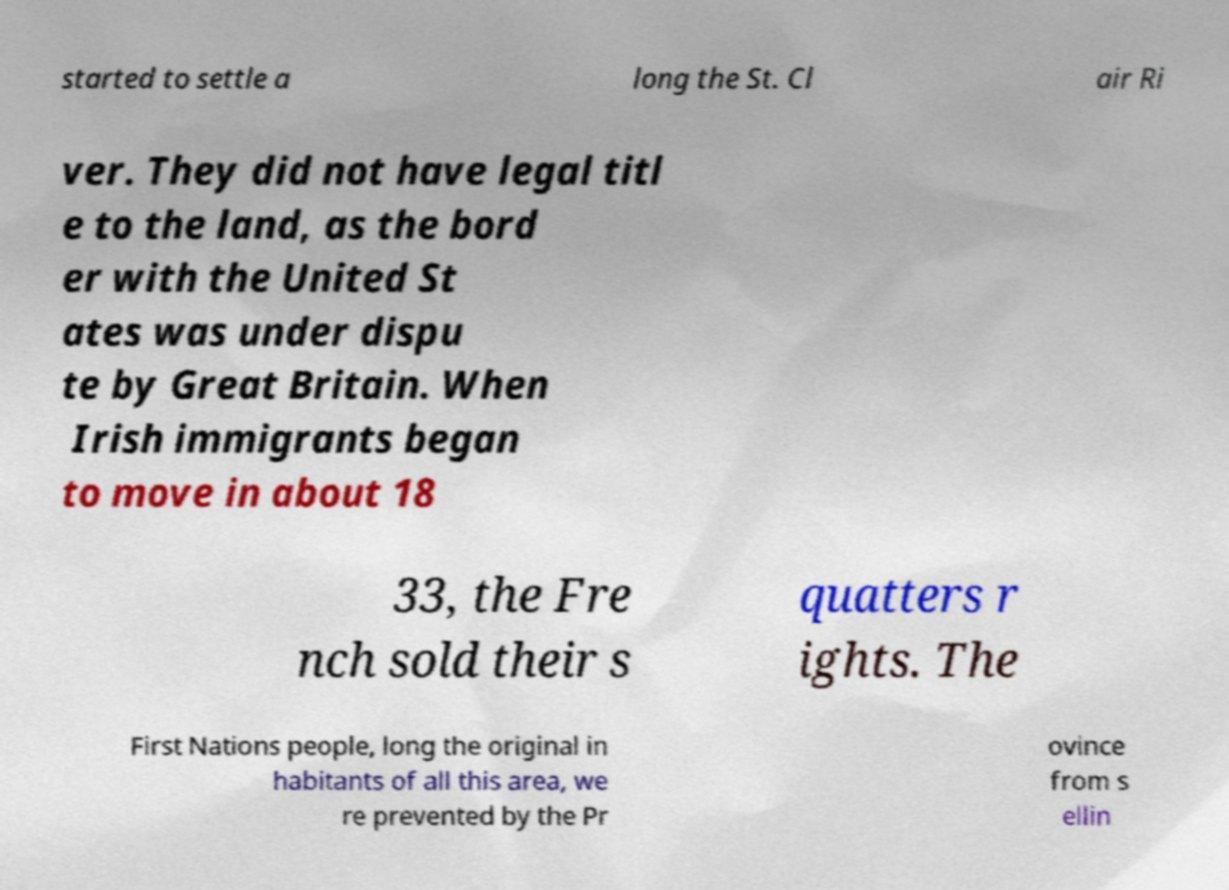Can you read and provide the text displayed in the image?This photo seems to have some interesting text. Can you extract and type it out for me? started to settle a long the St. Cl air Ri ver. They did not have legal titl e to the land, as the bord er with the United St ates was under dispu te by Great Britain. When Irish immigrants began to move in about 18 33, the Fre nch sold their s quatters r ights. The First Nations people, long the original in habitants of all this area, we re prevented by the Pr ovince from s ellin 